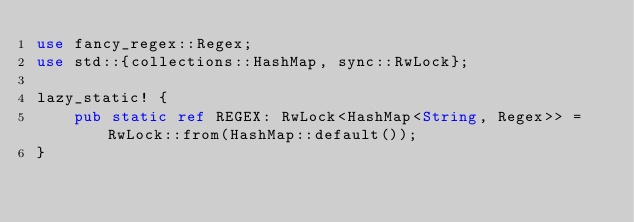<code> <loc_0><loc_0><loc_500><loc_500><_Rust_>use fancy_regex::Regex;
use std::{collections::HashMap, sync::RwLock};

lazy_static! {
    pub static ref REGEX: RwLock<HashMap<String, Regex>> = RwLock::from(HashMap::default());
}
</code> 